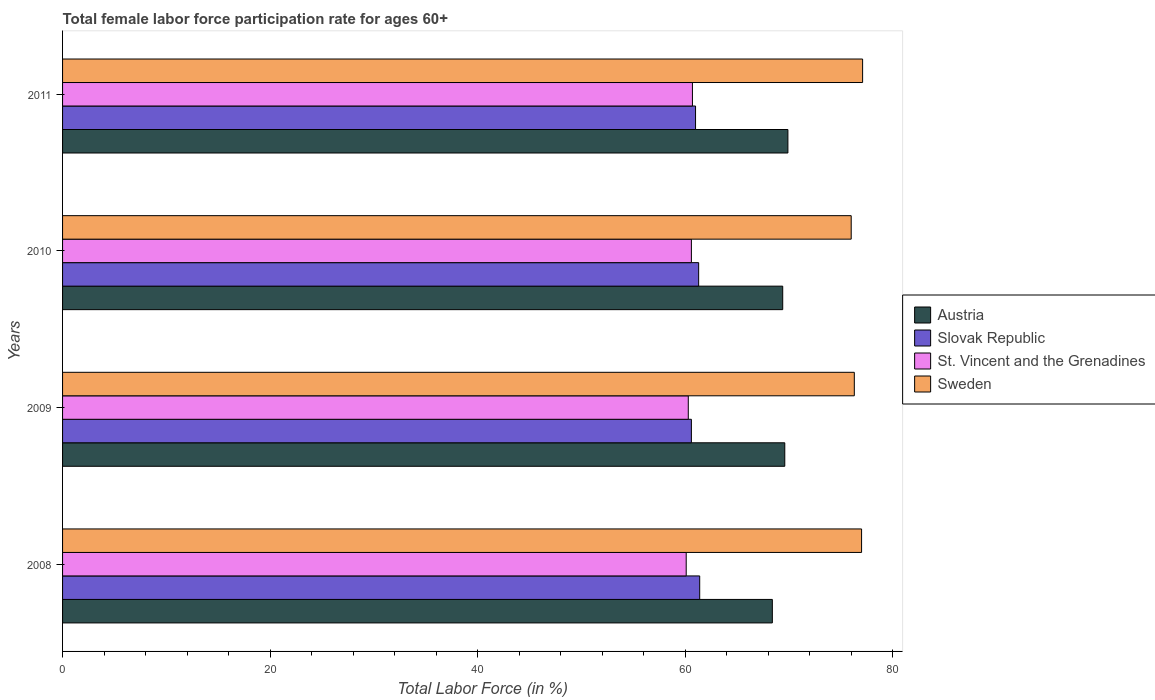How many different coloured bars are there?
Ensure brevity in your answer.  4. Are the number of bars per tick equal to the number of legend labels?
Provide a short and direct response. Yes. How many bars are there on the 4th tick from the top?
Your response must be concise. 4. How many bars are there on the 4th tick from the bottom?
Make the answer very short. 4. What is the label of the 1st group of bars from the top?
Give a very brief answer. 2011. In how many cases, is the number of bars for a given year not equal to the number of legend labels?
Offer a very short reply. 0. What is the female labor force participation rate in Slovak Republic in 2008?
Offer a terse response. 61.4. Across all years, what is the maximum female labor force participation rate in Austria?
Offer a terse response. 69.9. Across all years, what is the minimum female labor force participation rate in St. Vincent and the Grenadines?
Your response must be concise. 60.1. In which year was the female labor force participation rate in Austria maximum?
Offer a very short reply. 2011. What is the total female labor force participation rate in Slovak Republic in the graph?
Offer a terse response. 244.3. What is the difference between the female labor force participation rate in Sweden in 2010 and that in 2011?
Offer a terse response. -1.1. What is the difference between the female labor force participation rate in St. Vincent and the Grenadines in 2009 and the female labor force participation rate in Austria in 2011?
Offer a very short reply. -9.6. What is the average female labor force participation rate in Sweden per year?
Provide a succinct answer. 76.6. In the year 2010, what is the difference between the female labor force participation rate in Slovak Republic and female labor force participation rate in St. Vincent and the Grenadines?
Ensure brevity in your answer.  0.7. In how many years, is the female labor force participation rate in St. Vincent and the Grenadines greater than 56 %?
Offer a terse response. 4. What is the ratio of the female labor force participation rate in Austria in 2009 to that in 2010?
Provide a succinct answer. 1. Is the female labor force participation rate in Sweden in 2009 less than that in 2011?
Offer a terse response. Yes. Is the difference between the female labor force participation rate in Slovak Republic in 2008 and 2010 greater than the difference between the female labor force participation rate in St. Vincent and the Grenadines in 2008 and 2010?
Offer a terse response. Yes. What is the difference between the highest and the second highest female labor force participation rate in Austria?
Your answer should be very brief. 0.3. What is the difference between the highest and the lowest female labor force participation rate in Austria?
Your response must be concise. 1.5. Is the sum of the female labor force participation rate in Sweden in 2008 and 2009 greater than the maximum female labor force participation rate in St. Vincent and the Grenadines across all years?
Offer a very short reply. Yes. Is it the case that in every year, the sum of the female labor force participation rate in Slovak Republic and female labor force participation rate in St. Vincent and the Grenadines is greater than the sum of female labor force participation rate in Sweden and female labor force participation rate in Austria?
Make the answer very short. Yes. What does the 1st bar from the bottom in 2009 represents?
Give a very brief answer. Austria. Is it the case that in every year, the sum of the female labor force participation rate in Slovak Republic and female labor force participation rate in Austria is greater than the female labor force participation rate in St. Vincent and the Grenadines?
Ensure brevity in your answer.  Yes. What is the difference between two consecutive major ticks on the X-axis?
Keep it short and to the point. 20. Are the values on the major ticks of X-axis written in scientific E-notation?
Make the answer very short. No. Does the graph contain any zero values?
Give a very brief answer. No. Where does the legend appear in the graph?
Your response must be concise. Center right. How many legend labels are there?
Offer a very short reply. 4. What is the title of the graph?
Your response must be concise. Total female labor force participation rate for ages 60+. What is the Total Labor Force (in %) of Austria in 2008?
Your answer should be compact. 68.4. What is the Total Labor Force (in %) in Slovak Republic in 2008?
Your response must be concise. 61.4. What is the Total Labor Force (in %) in St. Vincent and the Grenadines in 2008?
Offer a very short reply. 60.1. What is the Total Labor Force (in %) in Sweden in 2008?
Your response must be concise. 77. What is the Total Labor Force (in %) in Austria in 2009?
Provide a succinct answer. 69.6. What is the Total Labor Force (in %) in Slovak Republic in 2009?
Keep it short and to the point. 60.6. What is the Total Labor Force (in %) in St. Vincent and the Grenadines in 2009?
Your response must be concise. 60.3. What is the Total Labor Force (in %) in Sweden in 2009?
Your response must be concise. 76.3. What is the Total Labor Force (in %) of Austria in 2010?
Ensure brevity in your answer.  69.4. What is the Total Labor Force (in %) in Slovak Republic in 2010?
Provide a succinct answer. 61.3. What is the Total Labor Force (in %) of St. Vincent and the Grenadines in 2010?
Ensure brevity in your answer.  60.6. What is the Total Labor Force (in %) of Austria in 2011?
Keep it short and to the point. 69.9. What is the Total Labor Force (in %) in St. Vincent and the Grenadines in 2011?
Keep it short and to the point. 60.7. What is the Total Labor Force (in %) in Sweden in 2011?
Offer a very short reply. 77.1. Across all years, what is the maximum Total Labor Force (in %) in Austria?
Provide a succinct answer. 69.9. Across all years, what is the maximum Total Labor Force (in %) in Slovak Republic?
Make the answer very short. 61.4. Across all years, what is the maximum Total Labor Force (in %) in St. Vincent and the Grenadines?
Your answer should be compact. 60.7. Across all years, what is the maximum Total Labor Force (in %) in Sweden?
Your response must be concise. 77.1. Across all years, what is the minimum Total Labor Force (in %) of Austria?
Your response must be concise. 68.4. Across all years, what is the minimum Total Labor Force (in %) in Slovak Republic?
Offer a terse response. 60.6. Across all years, what is the minimum Total Labor Force (in %) in St. Vincent and the Grenadines?
Keep it short and to the point. 60.1. What is the total Total Labor Force (in %) of Austria in the graph?
Your answer should be very brief. 277.3. What is the total Total Labor Force (in %) in Slovak Republic in the graph?
Offer a very short reply. 244.3. What is the total Total Labor Force (in %) of St. Vincent and the Grenadines in the graph?
Give a very brief answer. 241.7. What is the total Total Labor Force (in %) in Sweden in the graph?
Ensure brevity in your answer.  306.4. What is the difference between the Total Labor Force (in %) of Austria in 2008 and that in 2009?
Provide a short and direct response. -1.2. What is the difference between the Total Labor Force (in %) of St. Vincent and the Grenadines in 2008 and that in 2009?
Make the answer very short. -0.2. What is the difference between the Total Labor Force (in %) of Sweden in 2008 and that in 2009?
Offer a terse response. 0.7. What is the difference between the Total Labor Force (in %) of Austria in 2008 and that in 2010?
Keep it short and to the point. -1. What is the difference between the Total Labor Force (in %) in Austria in 2008 and that in 2011?
Make the answer very short. -1.5. What is the difference between the Total Labor Force (in %) in Slovak Republic in 2008 and that in 2011?
Your response must be concise. 0.4. What is the difference between the Total Labor Force (in %) of St. Vincent and the Grenadines in 2008 and that in 2011?
Provide a succinct answer. -0.6. What is the difference between the Total Labor Force (in %) in Slovak Republic in 2009 and that in 2010?
Offer a terse response. -0.7. What is the difference between the Total Labor Force (in %) of Slovak Republic in 2009 and that in 2011?
Provide a short and direct response. -0.4. What is the difference between the Total Labor Force (in %) of St. Vincent and the Grenadines in 2009 and that in 2011?
Offer a terse response. -0.4. What is the difference between the Total Labor Force (in %) in Sweden in 2009 and that in 2011?
Offer a very short reply. -0.8. What is the difference between the Total Labor Force (in %) of Austria in 2010 and that in 2011?
Your response must be concise. -0.5. What is the difference between the Total Labor Force (in %) of St. Vincent and the Grenadines in 2010 and that in 2011?
Offer a terse response. -0.1. What is the difference between the Total Labor Force (in %) in Sweden in 2010 and that in 2011?
Make the answer very short. -1.1. What is the difference between the Total Labor Force (in %) of Austria in 2008 and the Total Labor Force (in %) of St. Vincent and the Grenadines in 2009?
Your answer should be very brief. 8.1. What is the difference between the Total Labor Force (in %) in Slovak Republic in 2008 and the Total Labor Force (in %) in Sweden in 2009?
Your response must be concise. -14.9. What is the difference between the Total Labor Force (in %) of St. Vincent and the Grenadines in 2008 and the Total Labor Force (in %) of Sweden in 2009?
Your answer should be very brief. -16.2. What is the difference between the Total Labor Force (in %) in Austria in 2008 and the Total Labor Force (in %) in Slovak Republic in 2010?
Ensure brevity in your answer.  7.1. What is the difference between the Total Labor Force (in %) in Austria in 2008 and the Total Labor Force (in %) in St. Vincent and the Grenadines in 2010?
Your answer should be compact. 7.8. What is the difference between the Total Labor Force (in %) of Austria in 2008 and the Total Labor Force (in %) of Sweden in 2010?
Offer a terse response. -7.6. What is the difference between the Total Labor Force (in %) of Slovak Republic in 2008 and the Total Labor Force (in %) of Sweden in 2010?
Offer a very short reply. -14.6. What is the difference between the Total Labor Force (in %) of St. Vincent and the Grenadines in 2008 and the Total Labor Force (in %) of Sweden in 2010?
Provide a succinct answer. -15.9. What is the difference between the Total Labor Force (in %) in Austria in 2008 and the Total Labor Force (in %) in Sweden in 2011?
Offer a terse response. -8.7. What is the difference between the Total Labor Force (in %) of Slovak Republic in 2008 and the Total Labor Force (in %) of St. Vincent and the Grenadines in 2011?
Your response must be concise. 0.7. What is the difference between the Total Labor Force (in %) in Slovak Republic in 2008 and the Total Labor Force (in %) in Sweden in 2011?
Your answer should be very brief. -15.7. What is the difference between the Total Labor Force (in %) in St. Vincent and the Grenadines in 2008 and the Total Labor Force (in %) in Sweden in 2011?
Give a very brief answer. -17. What is the difference between the Total Labor Force (in %) of Austria in 2009 and the Total Labor Force (in %) of Slovak Republic in 2010?
Your response must be concise. 8.3. What is the difference between the Total Labor Force (in %) of Austria in 2009 and the Total Labor Force (in %) of St. Vincent and the Grenadines in 2010?
Keep it short and to the point. 9. What is the difference between the Total Labor Force (in %) of Slovak Republic in 2009 and the Total Labor Force (in %) of Sweden in 2010?
Offer a very short reply. -15.4. What is the difference between the Total Labor Force (in %) in St. Vincent and the Grenadines in 2009 and the Total Labor Force (in %) in Sweden in 2010?
Offer a terse response. -15.7. What is the difference between the Total Labor Force (in %) in Austria in 2009 and the Total Labor Force (in %) in Slovak Republic in 2011?
Ensure brevity in your answer.  8.6. What is the difference between the Total Labor Force (in %) of Austria in 2009 and the Total Labor Force (in %) of Sweden in 2011?
Offer a terse response. -7.5. What is the difference between the Total Labor Force (in %) in Slovak Republic in 2009 and the Total Labor Force (in %) in Sweden in 2011?
Give a very brief answer. -16.5. What is the difference between the Total Labor Force (in %) in St. Vincent and the Grenadines in 2009 and the Total Labor Force (in %) in Sweden in 2011?
Offer a very short reply. -16.8. What is the difference between the Total Labor Force (in %) of Austria in 2010 and the Total Labor Force (in %) of Sweden in 2011?
Offer a very short reply. -7.7. What is the difference between the Total Labor Force (in %) in Slovak Republic in 2010 and the Total Labor Force (in %) in St. Vincent and the Grenadines in 2011?
Your answer should be very brief. 0.6. What is the difference between the Total Labor Force (in %) of Slovak Republic in 2010 and the Total Labor Force (in %) of Sweden in 2011?
Provide a succinct answer. -15.8. What is the difference between the Total Labor Force (in %) of St. Vincent and the Grenadines in 2010 and the Total Labor Force (in %) of Sweden in 2011?
Give a very brief answer. -16.5. What is the average Total Labor Force (in %) of Austria per year?
Keep it short and to the point. 69.33. What is the average Total Labor Force (in %) in Slovak Republic per year?
Keep it short and to the point. 61.08. What is the average Total Labor Force (in %) in St. Vincent and the Grenadines per year?
Provide a short and direct response. 60.42. What is the average Total Labor Force (in %) of Sweden per year?
Offer a very short reply. 76.6. In the year 2008, what is the difference between the Total Labor Force (in %) in Austria and Total Labor Force (in %) in Slovak Republic?
Your answer should be very brief. 7. In the year 2008, what is the difference between the Total Labor Force (in %) in Austria and Total Labor Force (in %) in St. Vincent and the Grenadines?
Your response must be concise. 8.3. In the year 2008, what is the difference between the Total Labor Force (in %) of Slovak Republic and Total Labor Force (in %) of Sweden?
Give a very brief answer. -15.6. In the year 2008, what is the difference between the Total Labor Force (in %) of St. Vincent and the Grenadines and Total Labor Force (in %) of Sweden?
Your response must be concise. -16.9. In the year 2009, what is the difference between the Total Labor Force (in %) of Austria and Total Labor Force (in %) of Slovak Republic?
Make the answer very short. 9. In the year 2009, what is the difference between the Total Labor Force (in %) of Austria and Total Labor Force (in %) of St. Vincent and the Grenadines?
Offer a terse response. 9.3. In the year 2009, what is the difference between the Total Labor Force (in %) in Slovak Republic and Total Labor Force (in %) in St. Vincent and the Grenadines?
Keep it short and to the point. 0.3. In the year 2009, what is the difference between the Total Labor Force (in %) of Slovak Republic and Total Labor Force (in %) of Sweden?
Give a very brief answer. -15.7. In the year 2010, what is the difference between the Total Labor Force (in %) in Austria and Total Labor Force (in %) in St. Vincent and the Grenadines?
Your response must be concise. 8.8. In the year 2010, what is the difference between the Total Labor Force (in %) of Slovak Republic and Total Labor Force (in %) of St. Vincent and the Grenadines?
Your answer should be compact. 0.7. In the year 2010, what is the difference between the Total Labor Force (in %) of Slovak Republic and Total Labor Force (in %) of Sweden?
Your answer should be very brief. -14.7. In the year 2010, what is the difference between the Total Labor Force (in %) of St. Vincent and the Grenadines and Total Labor Force (in %) of Sweden?
Offer a very short reply. -15.4. In the year 2011, what is the difference between the Total Labor Force (in %) of Austria and Total Labor Force (in %) of St. Vincent and the Grenadines?
Offer a very short reply. 9.2. In the year 2011, what is the difference between the Total Labor Force (in %) of Austria and Total Labor Force (in %) of Sweden?
Ensure brevity in your answer.  -7.2. In the year 2011, what is the difference between the Total Labor Force (in %) in Slovak Republic and Total Labor Force (in %) in Sweden?
Give a very brief answer. -16.1. In the year 2011, what is the difference between the Total Labor Force (in %) in St. Vincent and the Grenadines and Total Labor Force (in %) in Sweden?
Give a very brief answer. -16.4. What is the ratio of the Total Labor Force (in %) in Austria in 2008 to that in 2009?
Keep it short and to the point. 0.98. What is the ratio of the Total Labor Force (in %) in Slovak Republic in 2008 to that in 2009?
Offer a very short reply. 1.01. What is the ratio of the Total Labor Force (in %) of St. Vincent and the Grenadines in 2008 to that in 2009?
Keep it short and to the point. 1. What is the ratio of the Total Labor Force (in %) in Sweden in 2008 to that in 2009?
Your answer should be very brief. 1.01. What is the ratio of the Total Labor Force (in %) in Austria in 2008 to that in 2010?
Offer a very short reply. 0.99. What is the ratio of the Total Labor Force (in %) of Slovak Republic in 2008 to that in 2010?
Give a very brief answer. 1. What is the ratio of the Total Labor Force (in %) of Sweden in 2008 to that in 2010?
Provide a short and direct response. 1.01. What is the ratio of the Total Labor Force (in %) of Austria in 2008 to that in 2011?
Your answer should be very brief. 0.98. What is the ratio of the Total Labor Force (in %) in Slovak Republic in 2008 to that in 2011?
Give a very brief answer. 1.01. What is the ratio of the Total Labor Force (in %) of St. Vincent and the Grenadines in 2008 to that in 2011?
Ensure brevity in your answer.  0.99. What is the ratio of the Total Labor Force (in %) of Sweden in 2008 to that in 2011?
Make the answer very short. 1. What is the ratio of the Total Labor Force (in %) in Austria in 2009 to that in 2011?
Keep it short and to the point. 1. What is the ratio of the Total Labor Force (in %) in Sweden in 2009 to that in 2011?
Give a very brief answer. 0.99. What is the ratio of the Total Labor Force (in %) in St. Vincent and the Grenadines in 2010 to that in 2011?
Ensure brevity in your answer.  1. What is the ratio of the Total Labor Force (in %) in Sweden in 2010 to that in 2011?
Your answer should be compact. 0.99. What is the difference between the highest and the second highest Total Labor Force (in %) of Austria?
Provide a short and direct response. 0.3. What is the difference between the highest and the second highest Total Labor Force (in %) of Slovak Republic?
Your answer should be compact. 0.1. What is the difference between the highest and the second highest Total Labor Force (in %) of St. Vincent and the Grenadines?
Keep it short and to the point. 0.1. What is the difference between the highest and the lowest Total Labor Force (in %) of St. Vincent and the Grenadines?
Ensure brevity in your answer.  0.6. What is the difference between the highest and the lowest Total Labor Force (in %) of Sweden?
Provide a short and direct response. 1.1. 